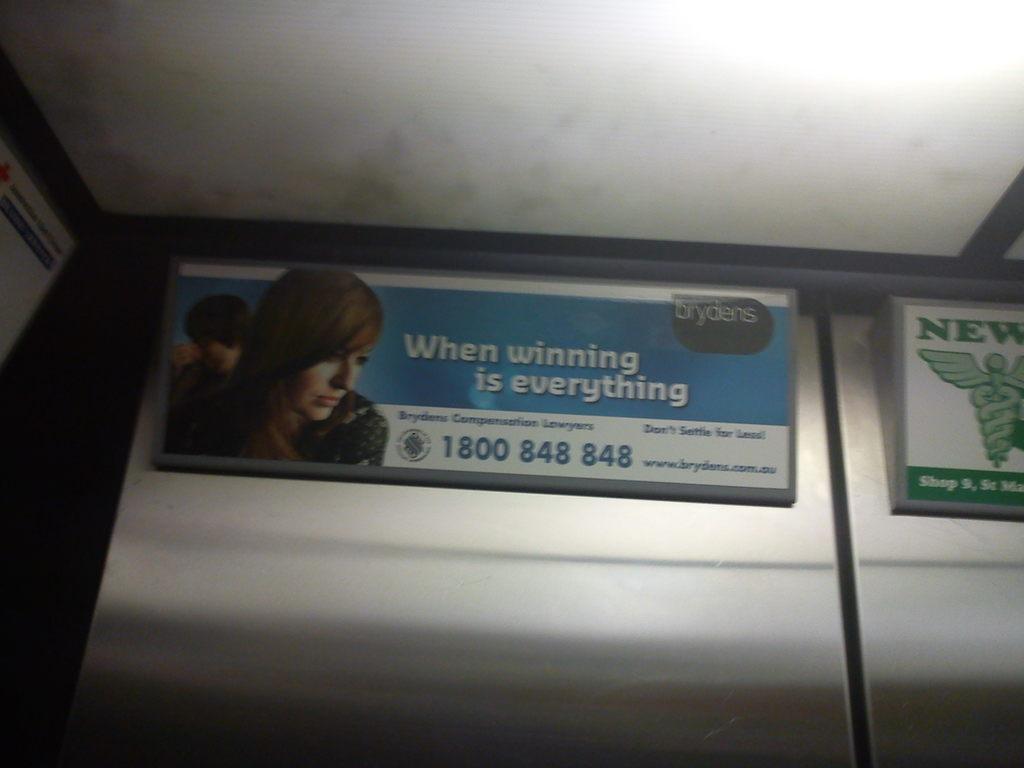Could you give a brief overview of what you see in this image? In this picture we can see name boards on the wall, on these name boards we can see people, symbols and some text on it and in the background we can see a roof. 